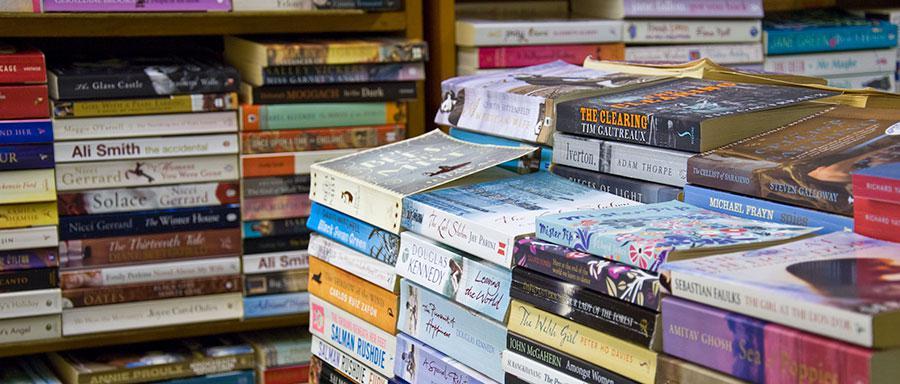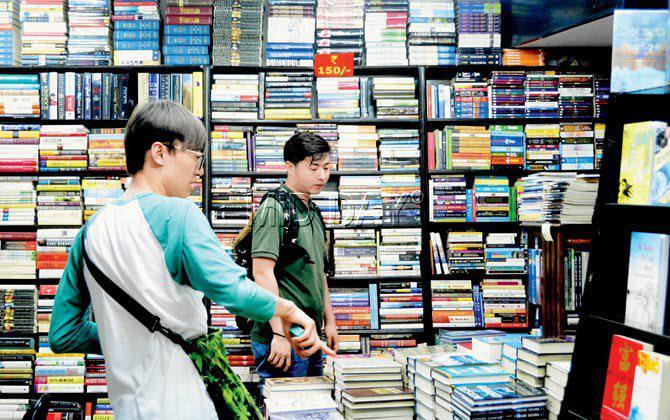The first image is the image on the left, the second image is the image on the right. Analyze the images presented: Is the assertion "At least 2 people are shopping for books in the bookstore." valid? Answer yes or no. Yes. The first image is the image on the left, the second image is the image on the right. For the images displayed, is the sentence "People stand in the book store in the image on the right." factually correct? Answer yes or no. Yes. 